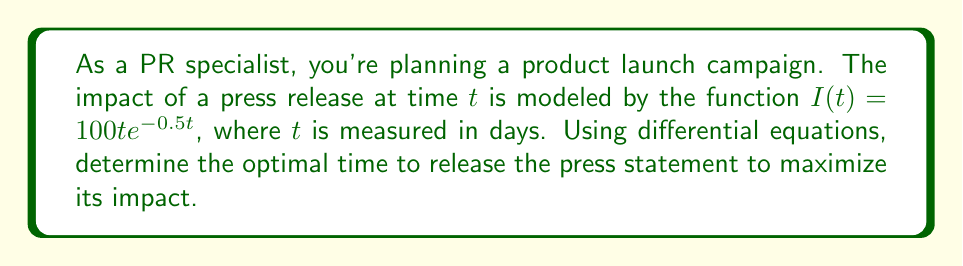Help me with this question. To find the optimal time for maximum impact, we need to find the maximum of the function $I(t)$. This can be done by finding where the derivative of $I(t)$ equals zero.

Step 1: Calculate the derivative of $I(t)$
$$\frac{d}{dt}I(t) = 100e^{-0.5t} + 100t(-0.5e^{-0.5t}) = 100e^{-0.5t}(1-0.5t)$$

Step 2: Set the derivative equal to zero and solve for $t$
$$100e^{-0.5t}(1-0.5t) = 0$$
Since $e^{-0.5t}$ is never zero, we solve:
$$1-0.5t = 0$$
$$-0.5t = -1$$
$$t = 2$$

Step 3: Verify this is a maximum (not a minimum) by checking the second derivative
$$\frac{d^2}{dt^2}I(t) = 100e^{-0.5t}(-0.5)(1-0.5t) + 100e^{-0.5t}(-0.5) = 100e^{-0.5t}(-0.5-0.5+0.25t)$$
At $t=2$: $\frac{d^2}{dt^2}I(2) = 100e^{-1}(-0.75) < 0$, confirming a maximum.

Therefore, the optimal time to release the press statement is 2 days after the start of the campaign.
Answer: 2 days 